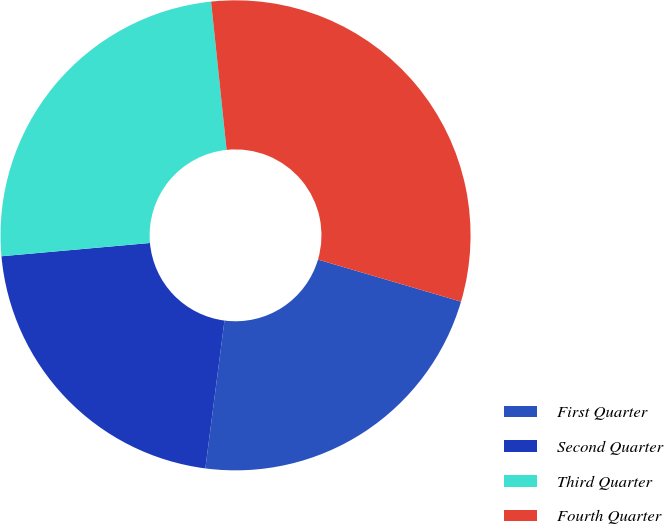Convert chart. <chart><loc_0><loc_0><loc_500><loc_500><pie_chart><fcel>First Quarter<fcel>Second Quarter<fcel>Third Quarter<fcel>Fourth Quarter<nl><fcel>22.5%<fcel>21.53%<fcel>24.76%<fcel>31.21%<nl></chart> 